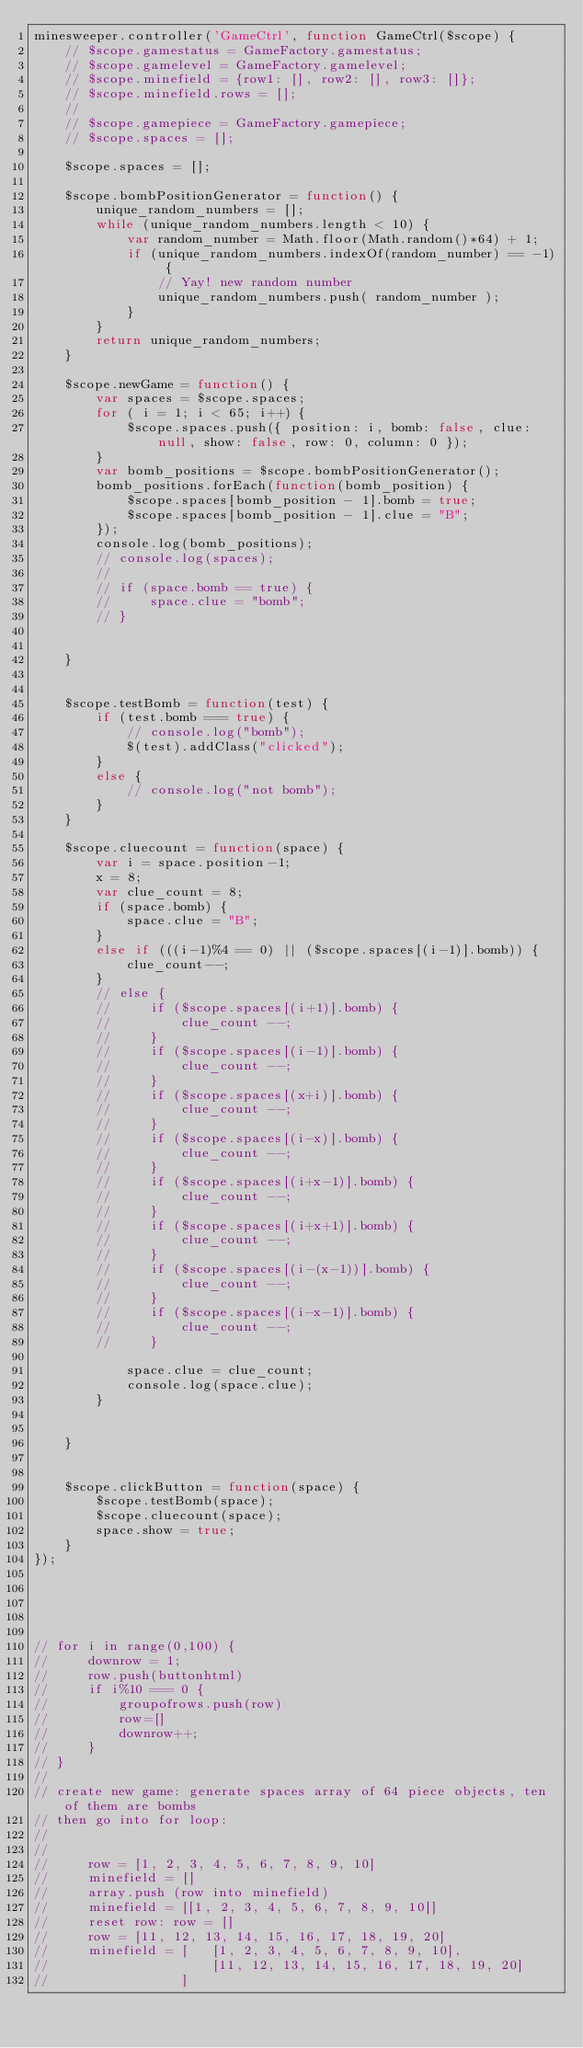Convert code to text. <code><loc_0><loc_0><loc_500><loc_500><_JavaScript_>minesweeper.controller('GameCtrl', function GameCtrl($scope) {
    // $scope.gamestatus = GameFactory.gamestatus;
    // $scope.gamelevel = GameFactory.gamelevel;
    // $scope.minefield = {row1: [], row2: [], row3: []};
    // $scope.minefield.rows = [];
    //
    // $scope.gamepiece = GameFactory.gamepiece;
    // $scope.spaces = [];

    $scope.spaces = [];

    $scope.bombPositionGenerator = function() {
        unique_random_numbers = [];
        while (unique_random_numbers.length < 10) {
            var random_number = Math.floor(Math.random()*64) + 1;
            if (unique_random_numbers.indexOf(random_number) == -1) {
                // Yay! new random number
                unique_random_numbers.push( random_number );
            }
        }
        return unique_random_numbers;
    }

    $scope.newGame = function() {
        var spaces = $scope.spaces;
        for ( i = 1; i < 65; i++) {
            $scope.spaces.push({ position: i, bomb: false, clue: null, show: false, row: 0, column: 0 });
        }
        var bomb_positions = $scope.bombPositionGenerator();
        bomb_positions.forEach(function(bomb_position) {
            $scope.spaces[bomb_position - 1].bomb = true;
            $scope.spaces[bomb_position - 1].clue = "B";
        });
        console.log(bomb_positions);
        // console.log(spaces);
        //
        // if (space.bomb == true) {
        //     space.clue = "bomb";
        // }


    }


    $scope.testBomb = function(test) {
        if (test.bomb === true) {
            // console.log("bomb");
            $(test).addClass("clicked");
        }
        else {
            // console.log("not bomb");
        }
    }

    $scope.cluecount = function(space) {
        var i = space.position-1;
        x = 8;
        var clue_count = 8;
        if (space.bomb) {
            space.clue = "B";
        }
        else if (((i-1)%4 == 0) || ($scope.spaces[(i-1)].bomb)) {
            clue_count--;
        }
        // else {
        //     if ($scope.spaces[(i+1)].bomb) {
        //         clue_count --;
        //     }
        //     if ($scope.spaces[(i-1)].bomb) {
        //         clue_count --;
        //     }
        //     if ($scope.spaces[(x+i)].bomb) {
        //         clue_count --;
        //     }
        //     if ($scope.spaces[(i-x)].bomb) {
        //         clue_count --;
        //     }
        //     if ($scope.spaces[(i+x-1)].bomb) {
        //         clue_count --;
        //     }
        //     if ($scope.spaces[(i+x+1)].bomb) {
        //         clue_count --;
        //     }
        //     if ($scope.spaces[(i-(x-1))].bomb) {
        //         clue_count --;
        //     }
        //     if ($scope.spaces[(i-x-1)].bomb) {
        //         clue_count --;
        //     }

            space.clue = clue_count;
            console.log(space.clue);
        }


    }


    $scope.clickButton = function(space) {
        $scope.testBomb(space);
        $scope.cluecount(space);
        space.show = true;
    }
});





// for i in range(0,100) {
//     downrow = 1;
//     row.push(buttonhtml)
//     if i%10 === 0 {
//         groupofrows.push(row)
//         row=[]
//         downrow++;
//     }
// }
//
// create new game: generate spaces array of 64 piece objects, ten of them are bombs
// then go into for loop:
//
//
//     row = [1, 2, 3, 4, 5, 6, 7, 8, 9, 10]
//     minefield = []
//     array.push (row into minefield)
//     minefield = [[1, 2, 3, 4, 5, 6, 7, 8, 9, 10]]
//     reset row: row = []
//     row = [11, 12, 13, 14, 15, 16, 17, 18, 19, 20]
//     minefield = [   [1, 2, 3, 4, 5, 6, 7, 8, 9, 10],
//                     [11, 12, 13, 14, 15, 16, 17, 18, 19, 20]
//                 ]
</code> 